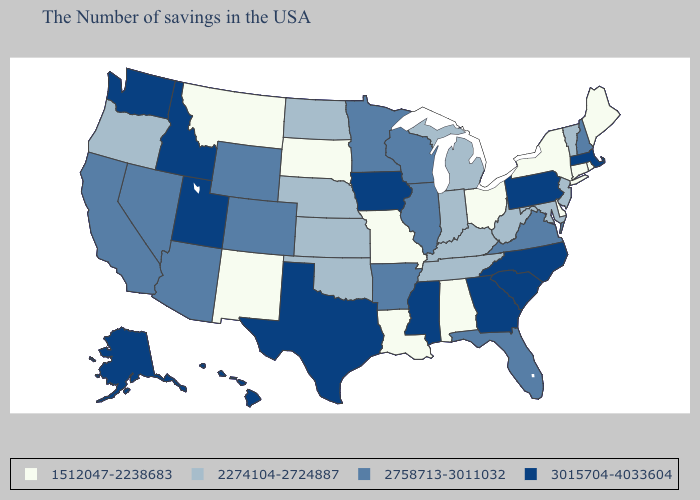Does Minnesota have the lowest value in the MidWest?
Keep it brief. No. Name the states that have a value in the range 2758713-3011032?
Quick response, please. New Hampshire, Virginia, Florida, Wisconsin, Illinois, Arkansas, Minnesota, Wyoming, Colorado, Arizona, Nevada, California. Is the legend a continuous bar?
Give a very brief answer. No. Name the states that have a value in the range 3015704-4033604?
Answer briefly. Massachusetts, Pennsylvania, North Carolina, South Carolina, Georgia, Mississippi, Iowa, Texas, Utah, Idaho, Washington, Alaska, Hawaii. Name the states that have a value in the range 2758713-3011032?
Write a very short answer. New Hampshire, Virginia, Florida, Wisconsin, Illinois, Arkansas, Minnesota, Wyoming, Colorado, Arizona, Nevada, California. Does the first symbol in the legend represent the smallest category?
Write a very short answer. Yes. What is the value of Tennessee?
Give a very brief answer. 2274104-2724887. Name the states that have a value in the range 2274104-2724887?
Answer briefly. Vermont, New Jersey, Maryland, West Virginia, Michigan, Kentucky, Indiana, Tennessee, Kansas, Nebraska, Oklahoma, North Dakota, Oregon. What is the lowest value in the USA?
Quick response, please. 1512047-2238683. What is the value of Mississippi?
Keep it brief. 3015704-4033604. Name the states that have a value in the range 2758713-3011032?
Quick response, please. New Hampshire, Virginia, Florida, Wisconsin, Illinois, Arkansas, Minnesota, Wyoming, Colorado, Arizona, Nevada, California. Name the states that have a value in the range 3015704-4033604?
Keep it brief. Massachusetts, Pennsylvania, North Carolina, South Carolina, Georgia, Mississippi, Iowa, Texas, Utah, Idaho, Washington, Alaska, Hawaii. Is the legend a continuous bar?
Short answer required. No. Which states have the highest value in the USA?
Write a very short answer. Massachusetts, Pennsylvania, North Carolina, South Carolina, Georgia, Mississippi, Iowa, Texas, Utah, Idaho, Washington, Alaska, Hawaii. What is the value of New Mexico?
Quick response, please. 1512047-2238683. 